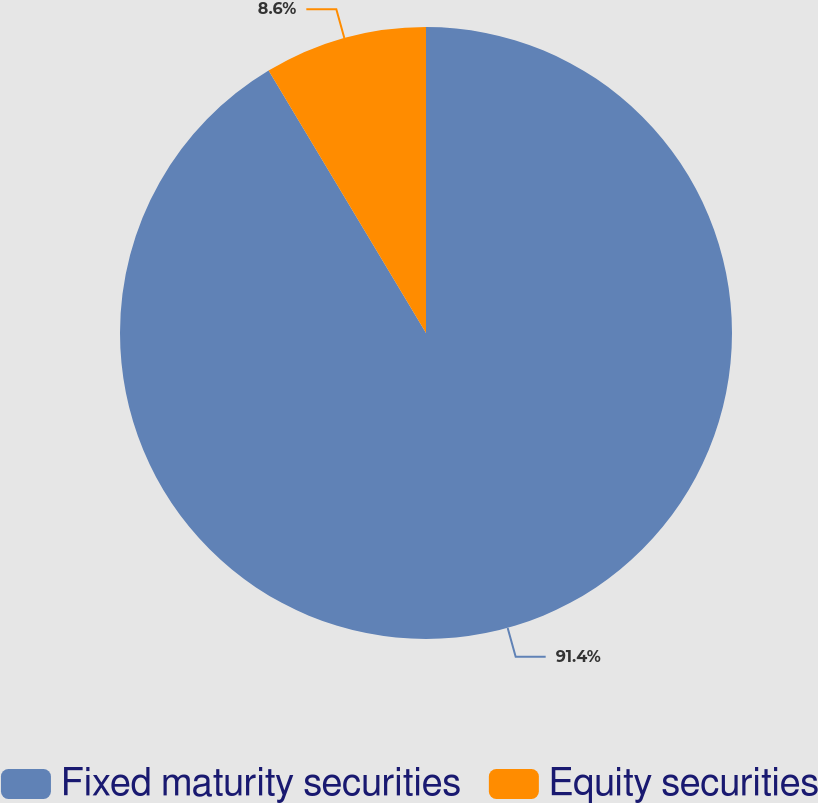Convert chart. <chart><loc_0><loc_0><loc_500><loc_500><pie_chart><fcel>Fixed maturity securities<fcel>Equity securities<nl><fcel>91.4%<fcel>8.6%<nl></chart> 